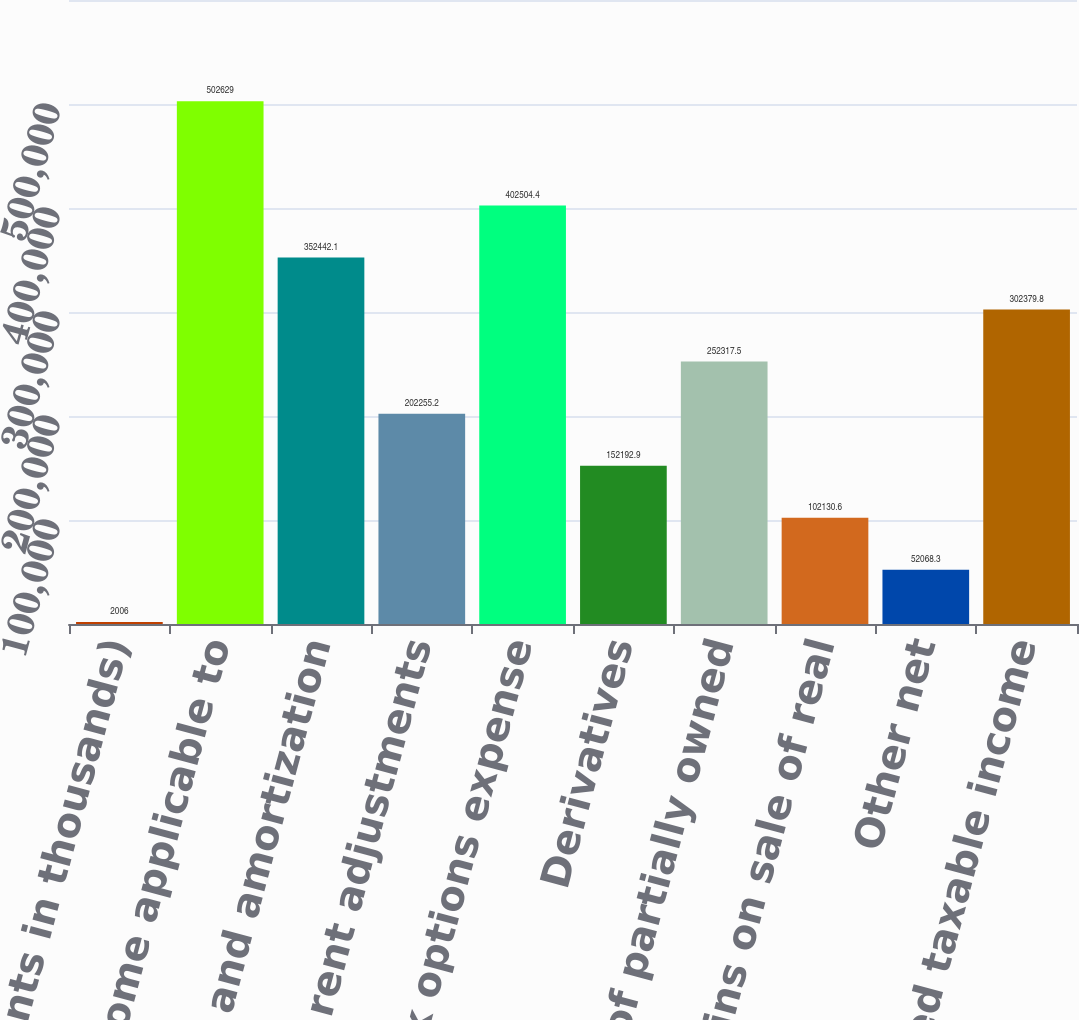<chart> <loc_0><loc_0><loc_500><loc_500><bar_chart><fcel>(Amounts in thousands)<fcel>Net income applicable to<fcel>Depreciation and amortization<fcel>Straight-line rent adjustments<fcel>Stock options expense<fcel>Derivatives<fcel>Earnings of partially owned<fcel>Net gains on sale of real<fcel>Other net<fcel>Estimated taxable income<nl><fcel>2006<fcel>502629<fcel>352442<fcel>202255<fcel>402504<fcel>152193<fcel>252318<fcel>102131<fcel>52068.3<fcel>302380<nl></chart> 